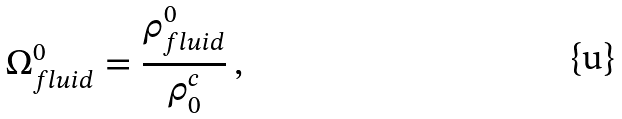<formula> <loc_0><loc_0><loc_500><loc_500>\Omega ^ { 0 } _ { f l u i d } = \frac { \rho ^ { 0 } _ { f l u i d } } { \rho _ { 0 } ^ { c } } \, ,</formula> 